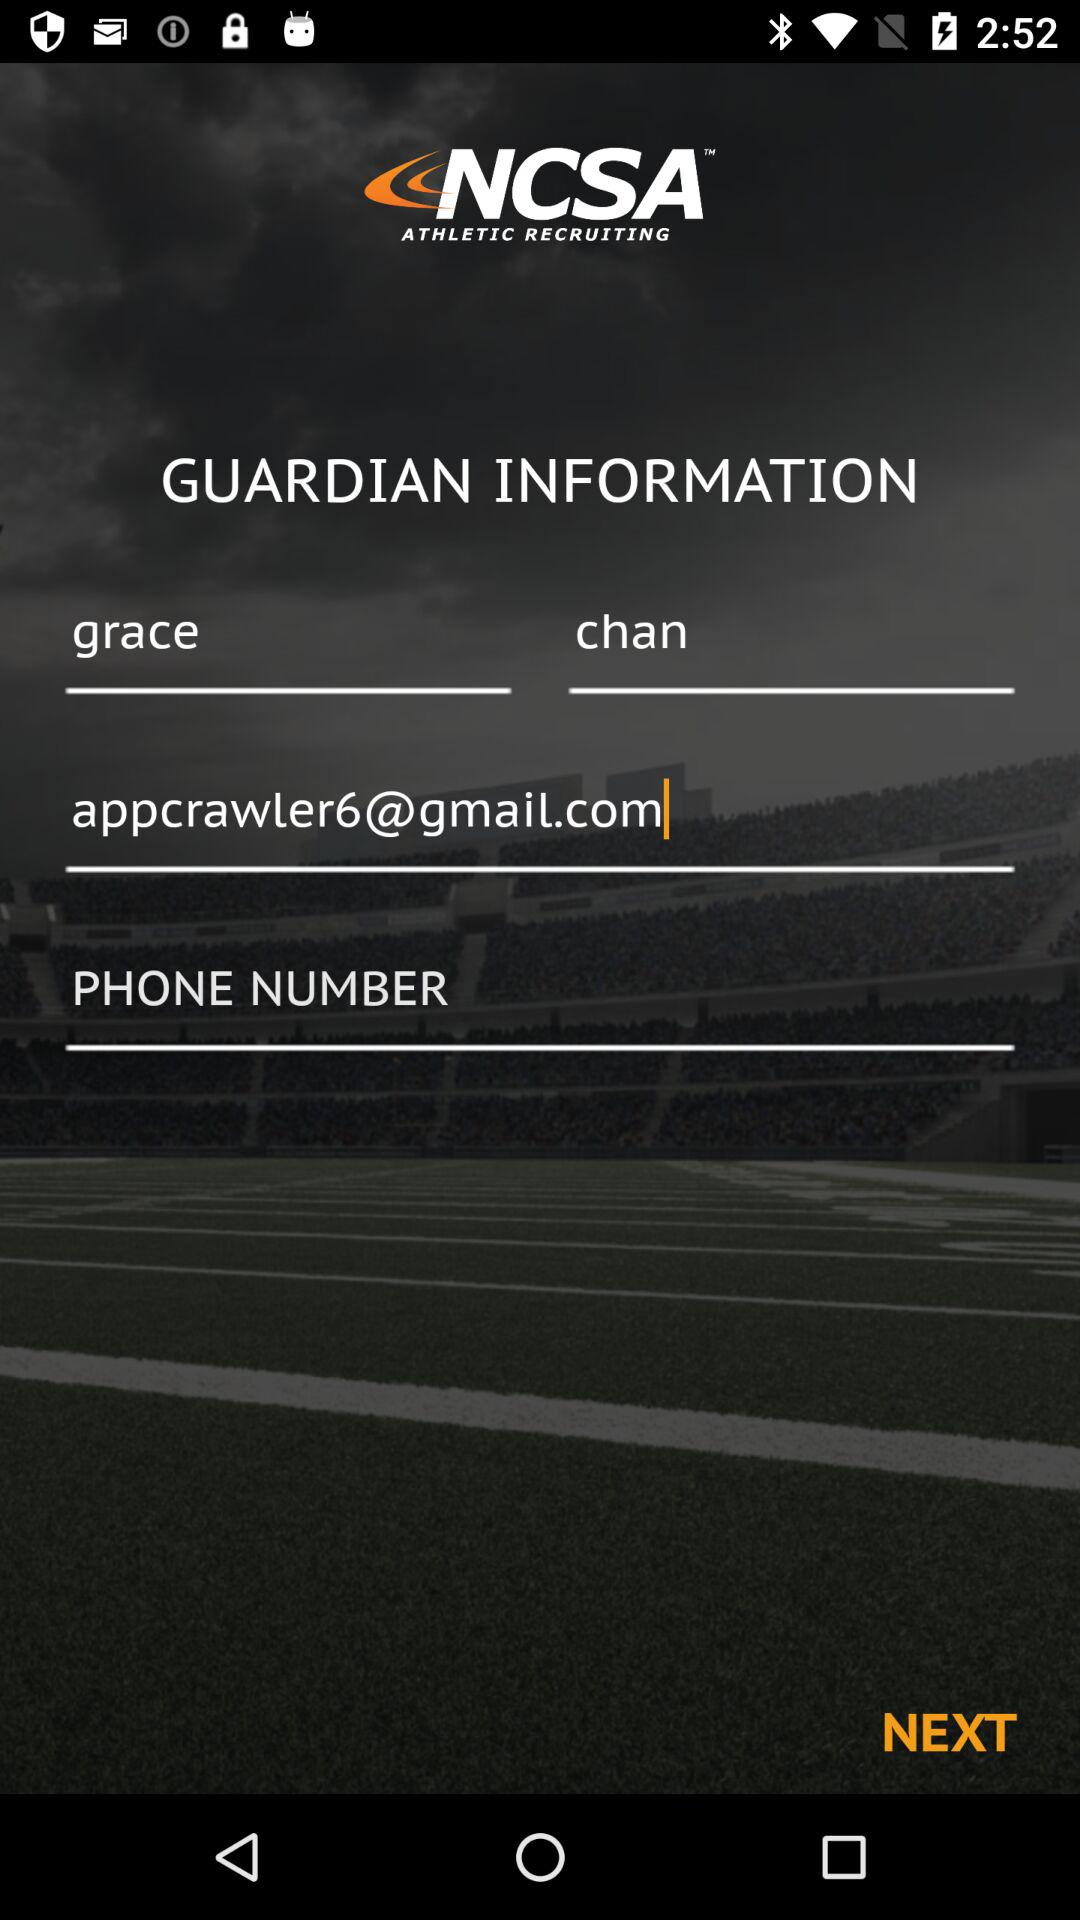What's the Gmail address? The Gmail address is appcrawler6@gmail.com. 